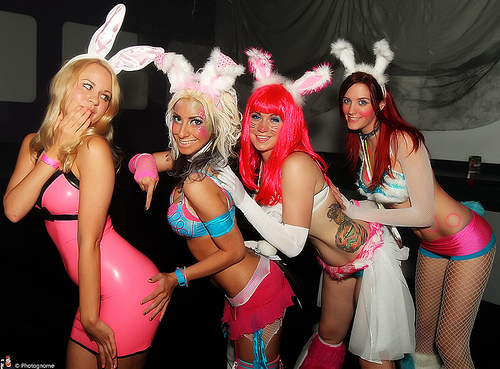<image>
Can you confirm if the bunny ears is on the woman? Yes. Looking at the image, I can see the bunny ears is positioned on top of the woman, with the woman providing support. 